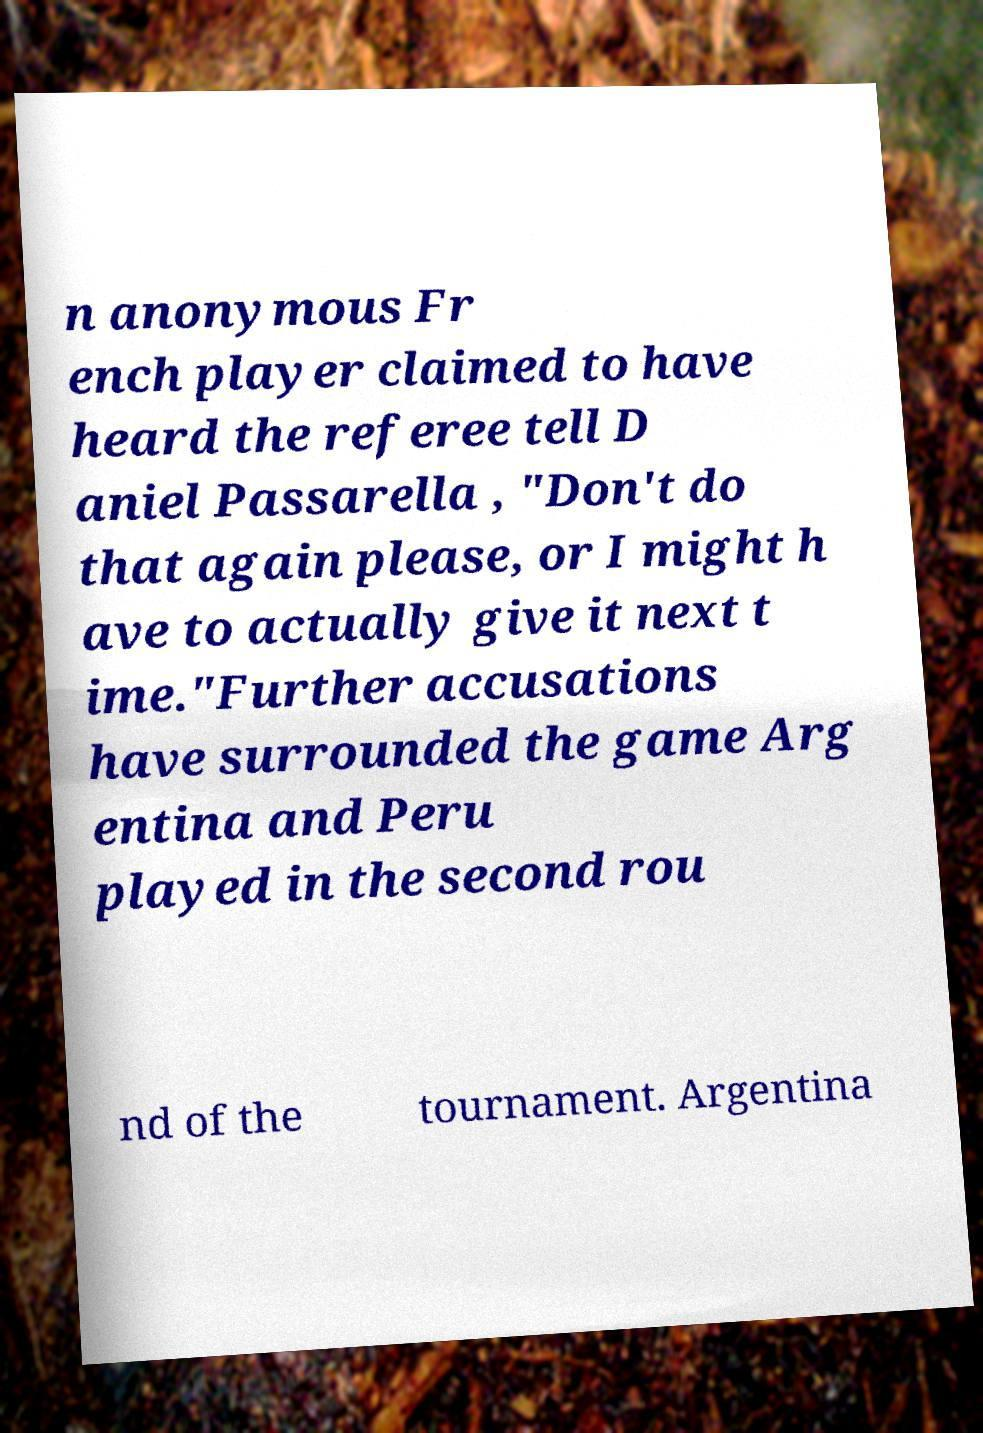Can you accurately transcribe the text from the provided image for me? n anonymous Fr ench player claimed to have heard the referee tell D aniel Passarella , "Don't do that again please, or I might h ave to actually give it next t ime."Further accusations have surrounded the game Arg entina and Peru played in the second rou nd of the tournament. Argentina 